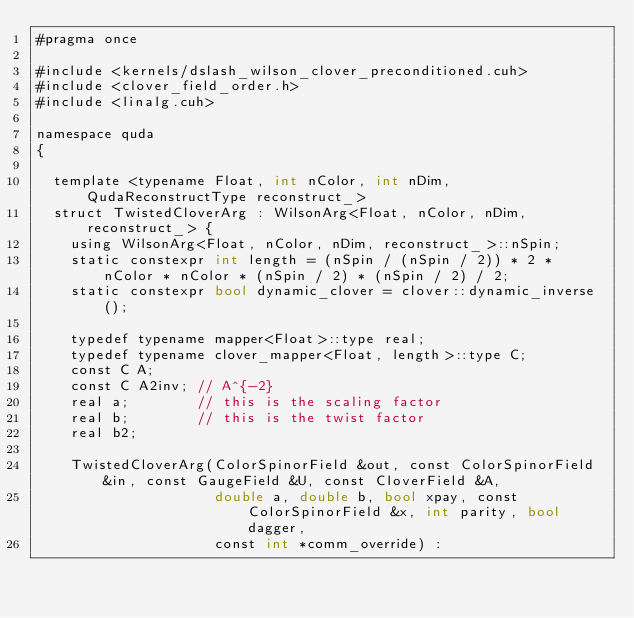Convert code to text. <code><loc_0><loc_0><loc_500><loc_500><_Cuda_>#pragma once

#include <kernels/dslash_wilson_clover_preconditioned.cuh>
#include <clover_field_order.h>
#include <linalg.cuh>

namespace quda
{

  template <typename Float, int nColor, int nDim, QudaReconstructType reconstruct_>
  struct TwistedCloverArg : WilsonArg<Float, nColor, nDim, reconstruct_> {
    using WilsonArg<Float, nColor, nDim, reconstruct_>::nSpin;
    static constexpr int length = (nSpin / (nSpin / 2)) * 2 * nColor * nColor * (nSpin / 2) * (nSpin / 2) / 2;
    static constexpr bool dynamic_clover = clover::dynamic_inverse();

    typedef typename mapper<Float>::type real;
    typedef typename clover_mapper<Float, length>::type C;
    const C A;
    const C A2inv; // A^{-2}
    real a;        // this is the scaling factor
    real b;        // this is the twist factor
    real b2;

    TwistedCloverArg(ColorSpinorField &out, const ColorSpinorField &in, const GaugeField &U, const CloverField &A,
                     double a, double b, bool xpay, const ColorSpinorField &x, int parity, bool dagger,
                     const int *comm_override) :</code> 